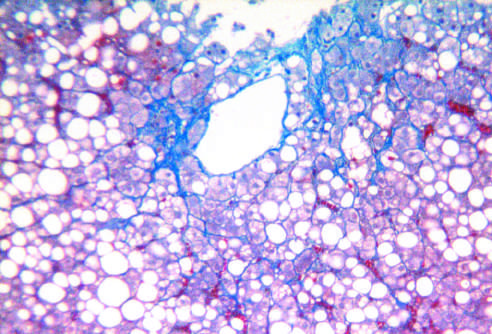how is fatty liver disease associated?
Answer the question using a single word or phrase. With chronic alcohol use 